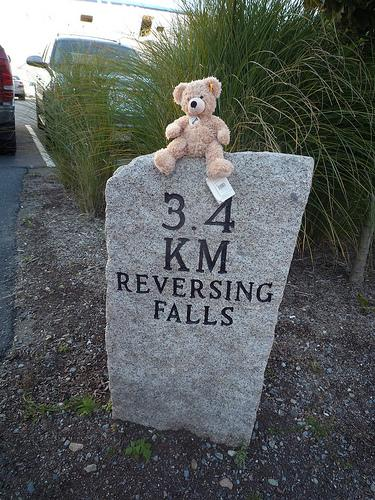How many tags are on the teddy bear, and what are their colors? There are two tags on the teddy bear: one yellow and one white. Can you please enumerate any text on the stone and their colors? Number 3 is black, number 4 is black, letters k, m, r, and e are black, and the words "reversing falls" are written on the stone. List the visible objects that are not the main subject and their locations in the image. Green weeds on the ground, large green bush in front of cars, stones and dirt on the ground, small green plant growing out of gravel, a large gray headstone, a wide green bush, a tail light on a red truck, cars in the background, street signs in the background, a red car in the background, and a pole above the cars. In terms of image quality, describe the clarity and composition of the image. The image is well-composed with a clear focus on the teddy bear, while the background objects add context and depth to the scene. What complex reasoning can be derived from the presence of a teddy bear on a town marker and a headstone with text? The teddy bear sitting on the town marker could symbolize a significant event or memory associated with the town, and the headstone with text might be a commemoration of someone related to both the town and the teddy bear, evoking a sense of remembrance and nostalgia. With regard to sentiment, describe the feeling or mood that the image evokes. The image evokes a peaceful and nostalgic mood, with the teddy bear sitting on the stone surrounded by nature. What is the primary object in the image and its color? A light brown teddy bear sitting on a large stone. Describe briefly the features of the teddy bear in the image. The teddy bear has a black nose, black eyes, brown ears, a yellow tag on its ear, and a white tag on its foot. Count how many cars and bushes there are in the background. There are at least 2 cars and 2 bushes in the background. Analyze the interaction between the main object and other objects or elements in the image. The teddy bear is sitting on a large stone, which creates a connection between the bear and the stone, while the surrounding elements such as green bushes and cars add a sense of context and environment to the scene. 